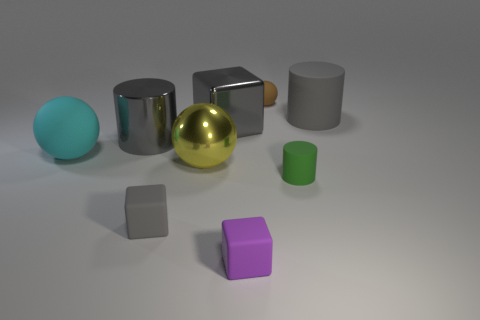Is the shape of the small purple thing the same as the small matte thing that is left of the purple rubber thing? yes 